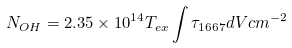Convert formula to latex. <formula><loc_0><loc_0><loc_500><loc_500>N _ { O H } = 2 . 3 5 \times 1 0 ^ { 1 4 } T _ { e x } \int \tau _ { 1 6 6 7 } d V c m ^ { - 2 }</formula> 